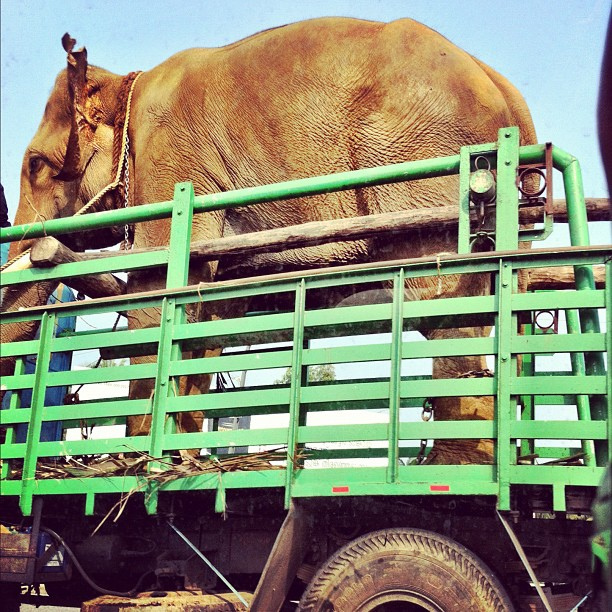<image>How did they get the elephant on the truck? I don't know how they got the elephant on the truck. It could be with a ramp or some other method. How did they get the elephant on the truck? It is unanswerable how they got the elephant on the truck. 